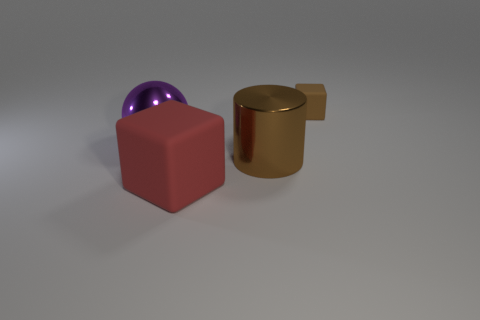Add 1 big red matte spheres. How many objects exist? 5 Subtract all balls. How many objects are left? 3 Subtract 0 purple blocks. How many objects are left? 4 Subtract all big cylinders. Subtract all brown matte things. How many objects are left? 2 Add 4 big cubes. How many big cubes are left? 5 Add 3 big purple metal things. How many big purple metal things exist? 4 